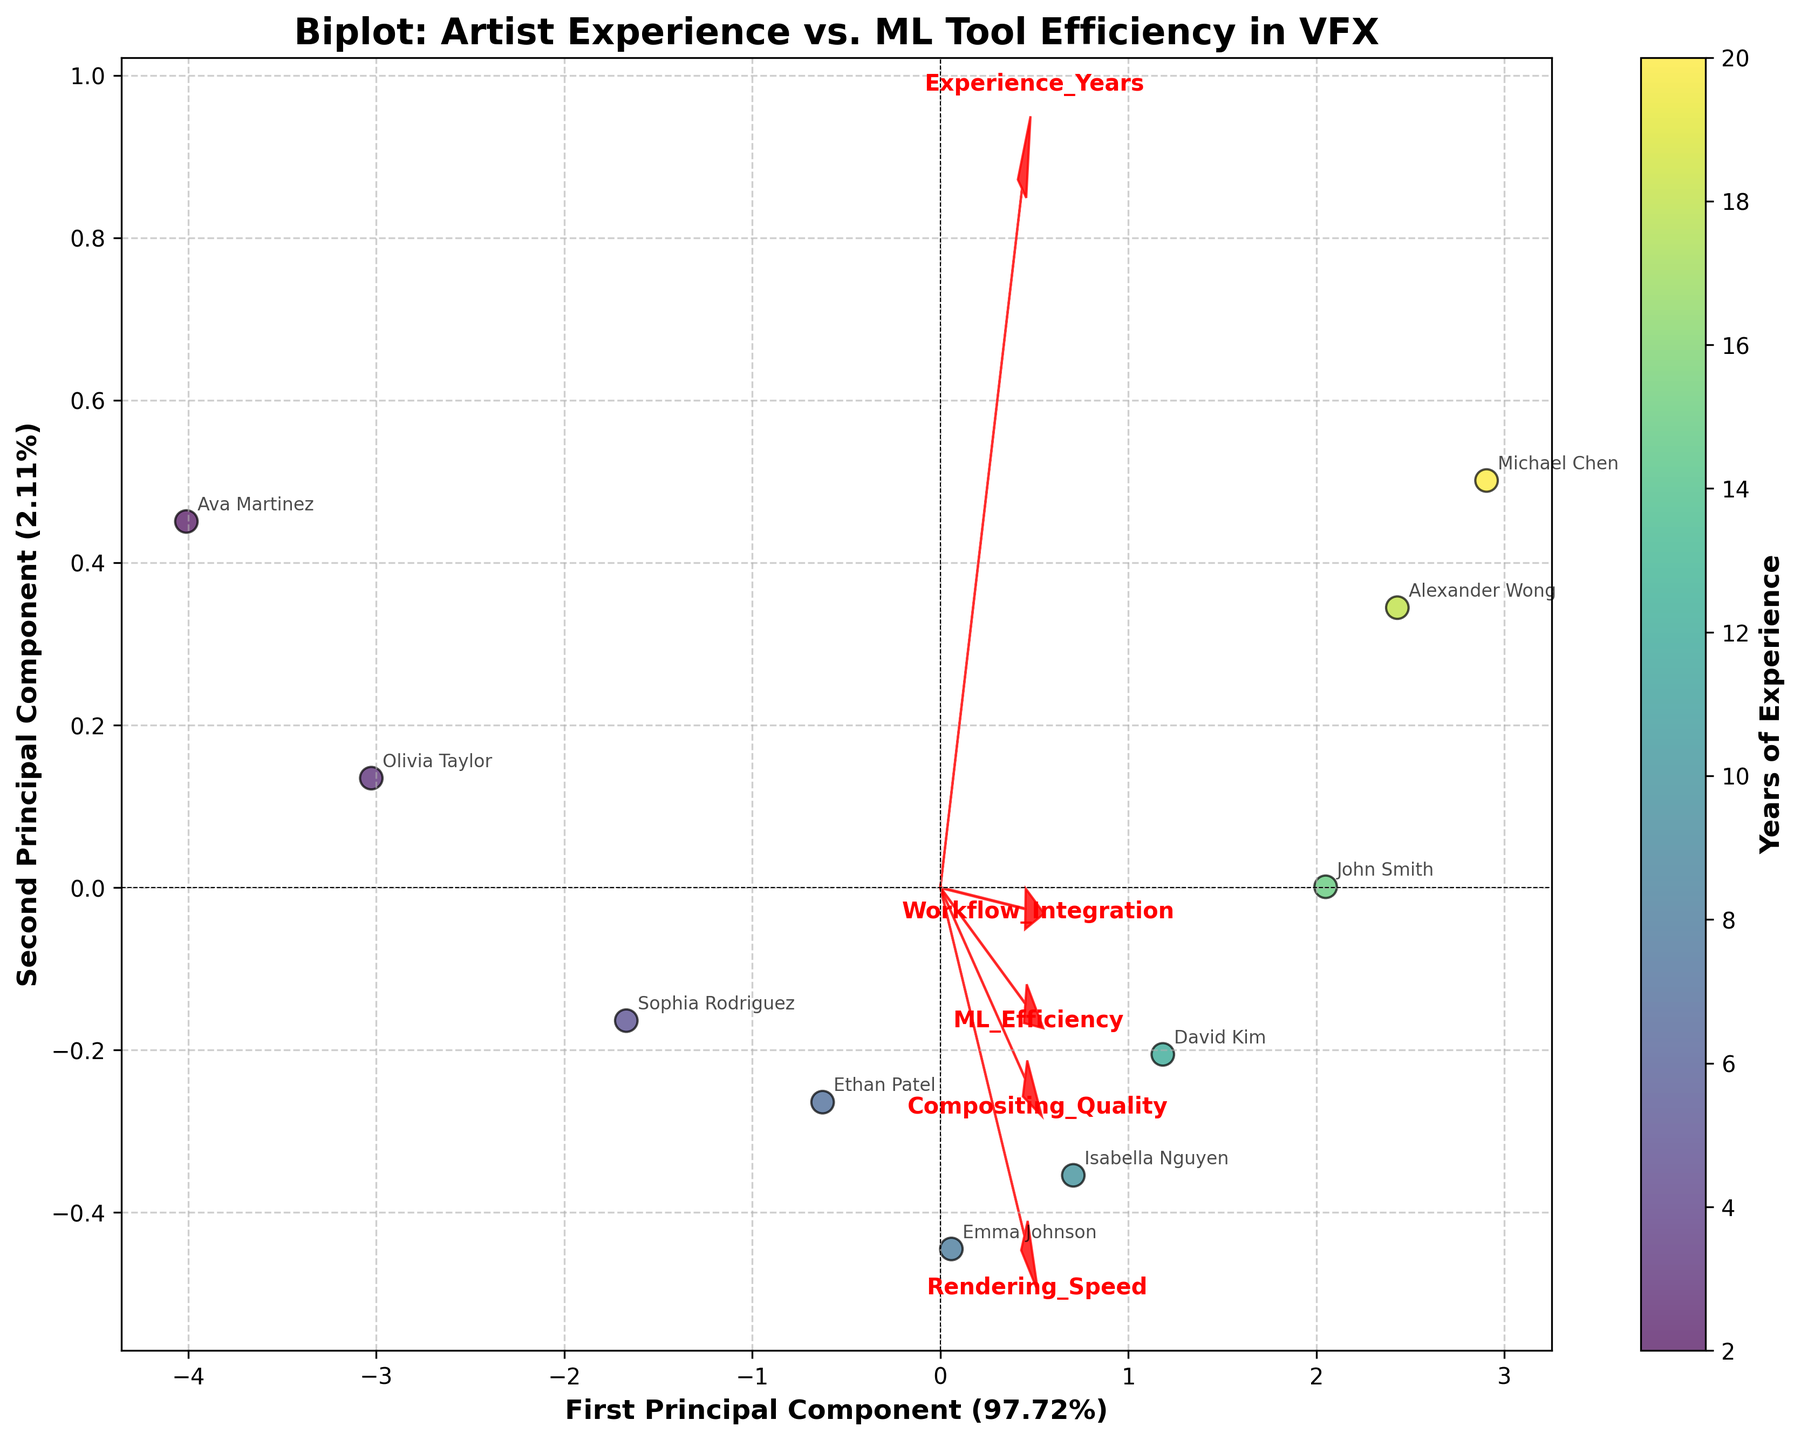What does the color of the scatter points represent? The color of the scatter points represents the number of years of experience each artist has. This is indicated by the color bar on the right side of the plot.
Answer: Years of experience What is represented by the arrows in the biplot? The arrows represent the principal component vectors for each of the features (Experience Years, ML Efficiency, Rendering Speed, Compositing Quality, Workflow Integration). The direction and length of the arrows show the contribution of each feature to the principal components.
Answer: Principal component vectors of features Which artist appears near the top right corner of the plot? The artist near the top right corner of the plot can be identified based on their scatter point's position and annotation.
Answer: Michael Chen What feature seems to have the largest contribution to the first principal component? To find the feature with the largest contribution to the first principal component, look for the arrow extending furthest horizontally from the center.
Answer: Experience Years Can you identify the artist with the least experience? The artist with the scatter point near the darkest end of the color bar, which corresponds to the least experience, is identified by their annotation.
Answer: Ava Martinez Which artist demonstrates high ML Efficiency but low Experience Years? To find this, look for a scatter point with high vertical placement (indicating high ML Efficiency) but relatively darker color (indicating fewer Experience Years).
Answer: Olivia Taylor What is the relationship between Experience Years and Workflow Integration based on the biplot vectors? To determine the relationship, check the direction of the vectors for Experience Years and Workflow Integration. If they point in the same direction or opposite direction, it indicates a positive or negative correlation respectively.
Answer: Positive correlation Which feature vectors are almost parallel to each other, indicating a potential strong correlation? By observing feature vectors that are nearly parallel, we can deduce the features that are strongly correlated.
Answer: Compositing Quality and Rendering Speed What percentage of variance is explained by the first principal component? The percentage of variance explained by the first principal component is stated on the x-axis label, following the principal component's name.
Answer: Approx. 49% Who is the artist with the highest Rendering Speed? The artist with the highest Rendering Speed will likely be positioned along the arrow corresponding to Rendering Speed and can be identified through their annotation.
Answer: Michael Chen 